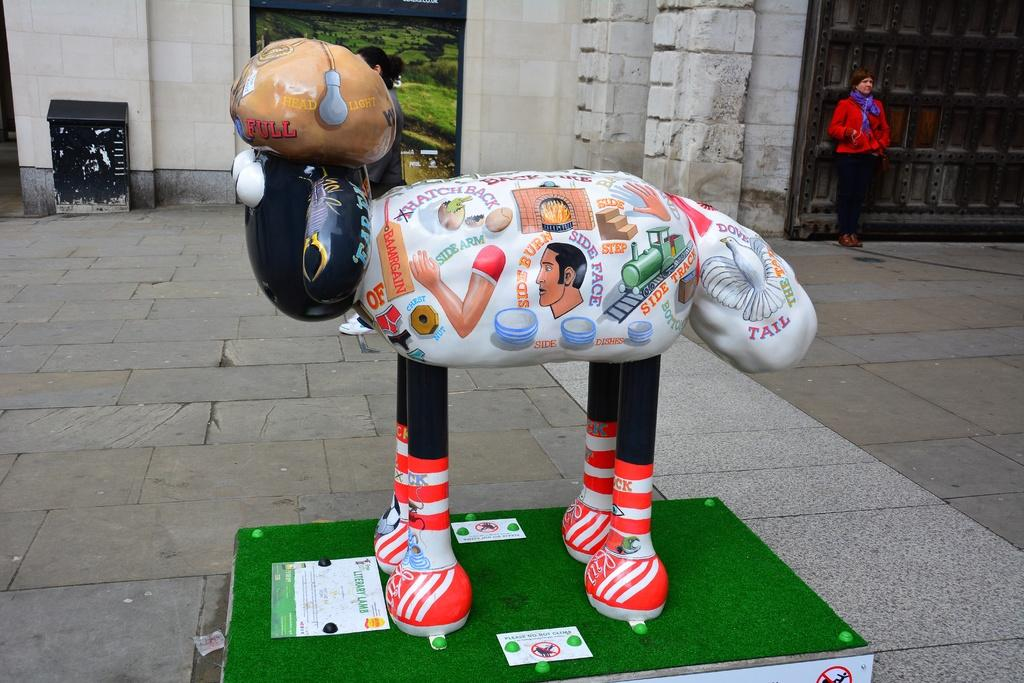What is the main subject in the image? There is a statue in the image. What can be seen on the platform in the image? There are posters on a platform. Can you describe the background of the image? In the background of the image, there is a person, a woman standing on the ground, grass, walls, and some objects. What is the surprise element in the image? There is no surprise element present in the image. What is the opinion of the statue about the grass in the background? The statue is an inanimate object and cannot have an opinion. 